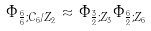<formula> <loc_0><loc_0><loc_500><loc_500>\Phi _ { \frac { 6 } { 6 } ; C _ { 6 } / Z _ { 2 } } \approx \Phi _ { \frac { 3 } { 2 } ; Z _ { 3 } } \Phi _ { \frac { 6 } { 2 } ; Z _ { 6 } }</formula> 